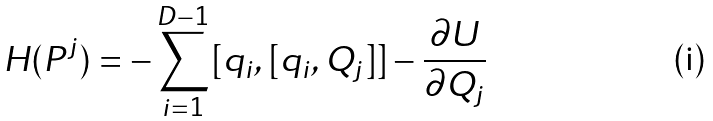<formula> <loc_0><loc_0><loc_500><loc_500>H ( P ^ { j } ) = - \sum _ { i = 1 } ^ { D - 1 } [ q _ { i } , [ q _ { i } , Q _ { j } ] ] - \frac { \partial U } { \partial Q _ { j } }</formula> 